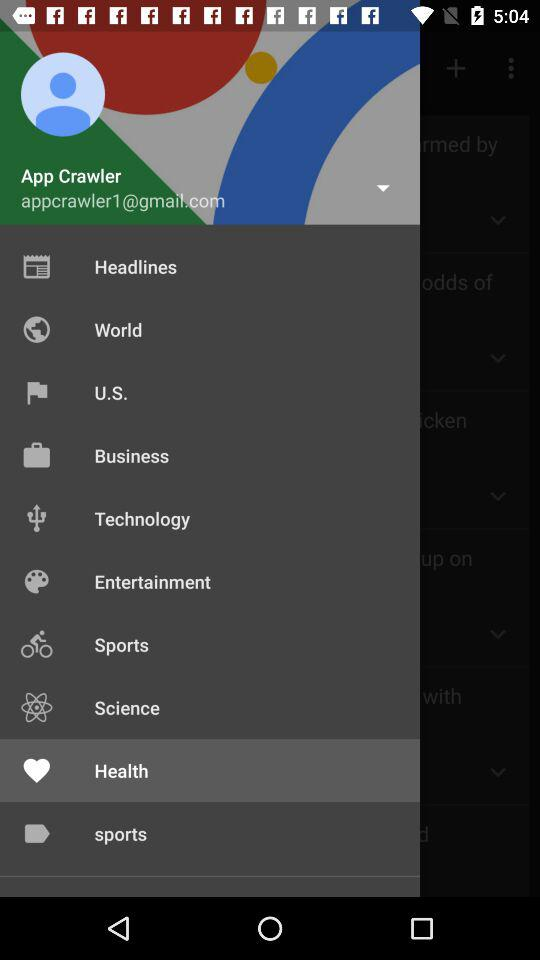What's the user profile name? The user profile name is App Crawler. 